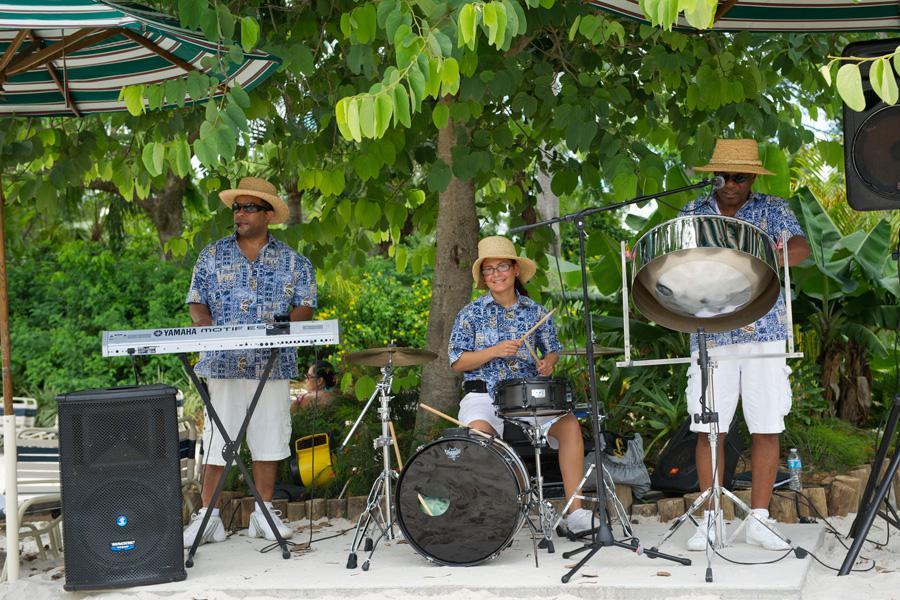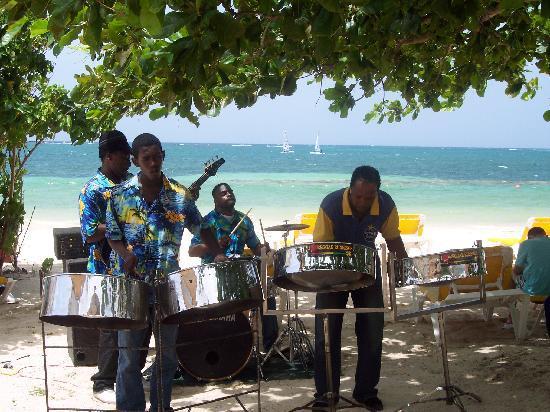The first image is the image on the left, the second image is the image on the right. Considering the images on both sides, is "In one of the images, three people in straw hats are playing instruments." valid? Answer yes or no. Yes. 